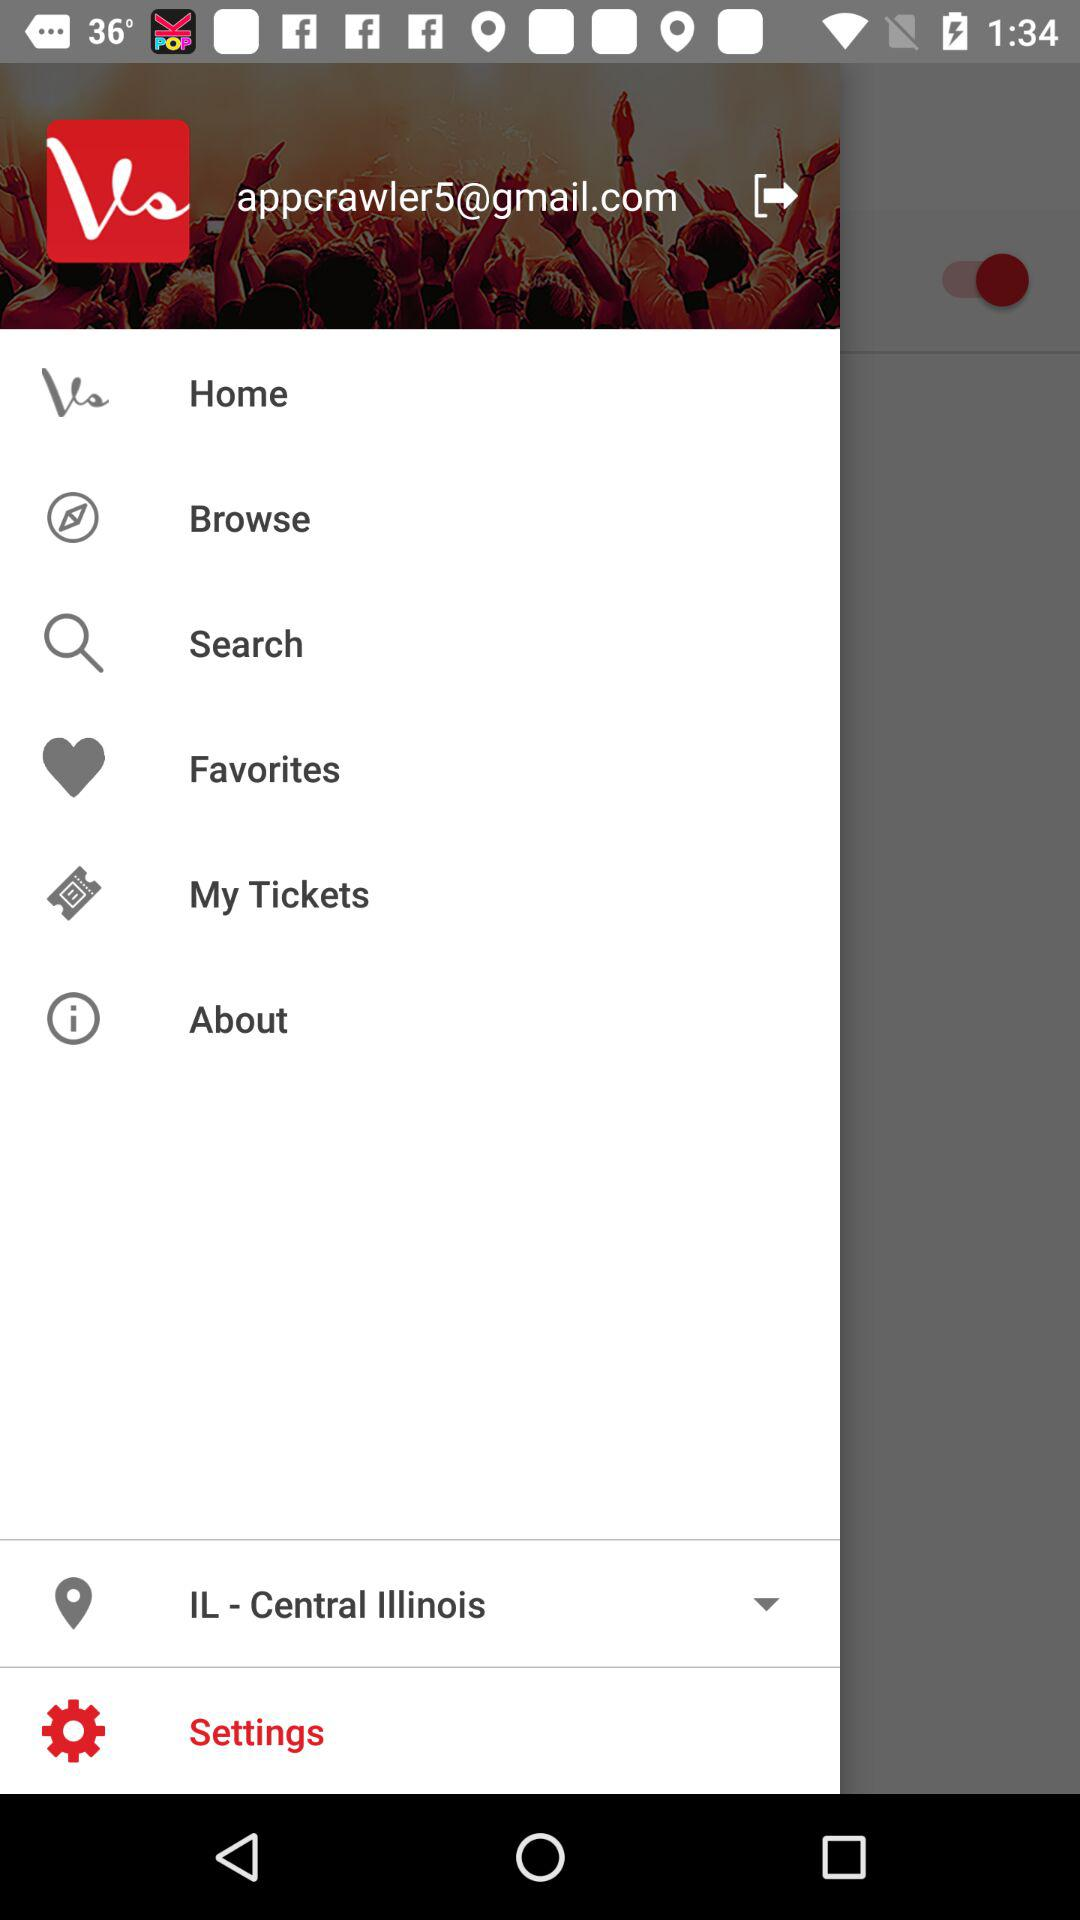What is the selected location? The selected location is Central Illinois, Illinois. 